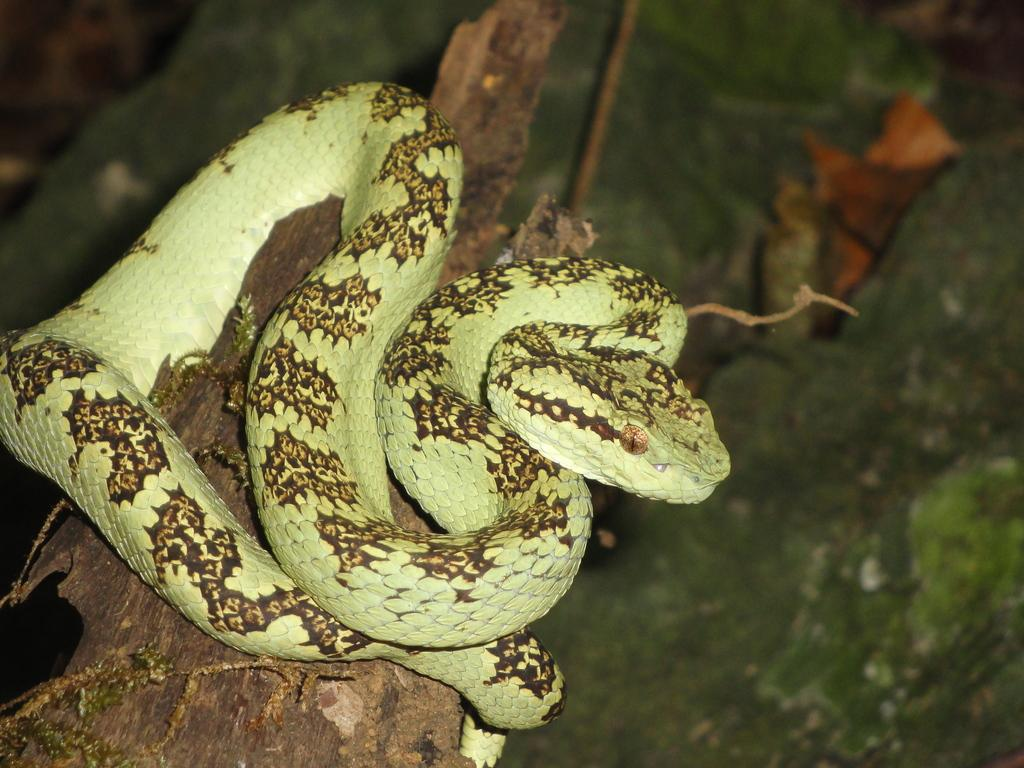What animal is present in the image? There is a snake in the image. Where is the snake located? The snake is on a tree trunk. Can you describe the background of the image? The background of the image is blurred. What type of yard is visible in the background of the image? There is no yard visible in the image; the background is blurred. 